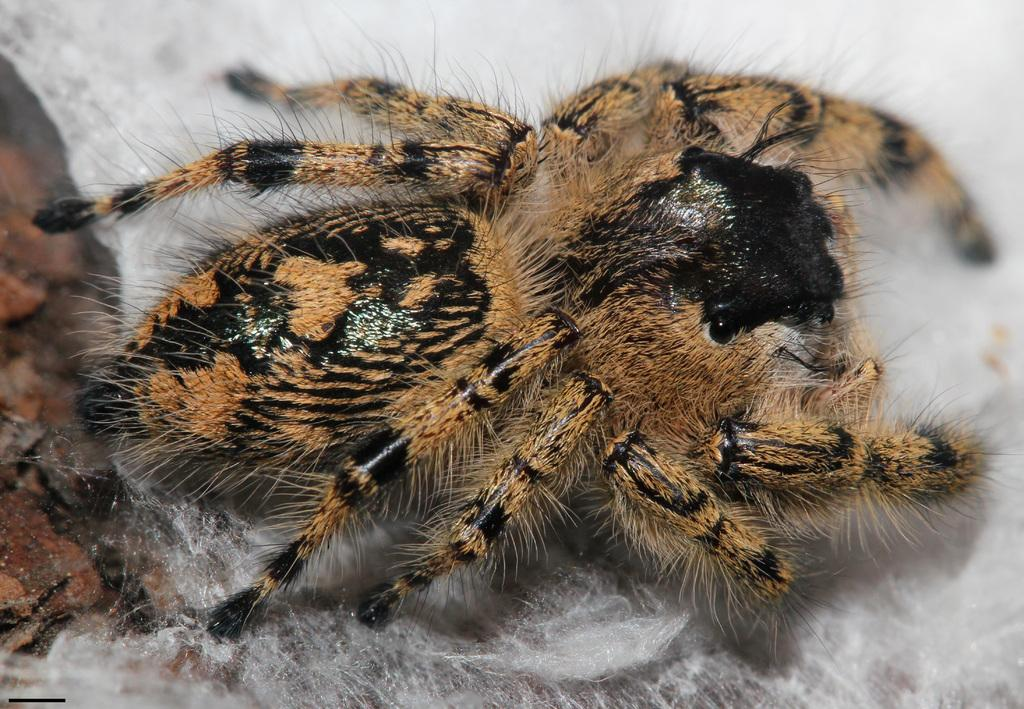What is the main subject of the image? The main subject of the image is a spider. Where is the spider located in the image? The spider is on a path in the image. What type of sponge can be seen near the spider in the image? There is no sponge present in the image; it features a spider on a path. What color is the bell that the spider is ringing in the image? There is no bell present in the image; it features a spider on a path. 